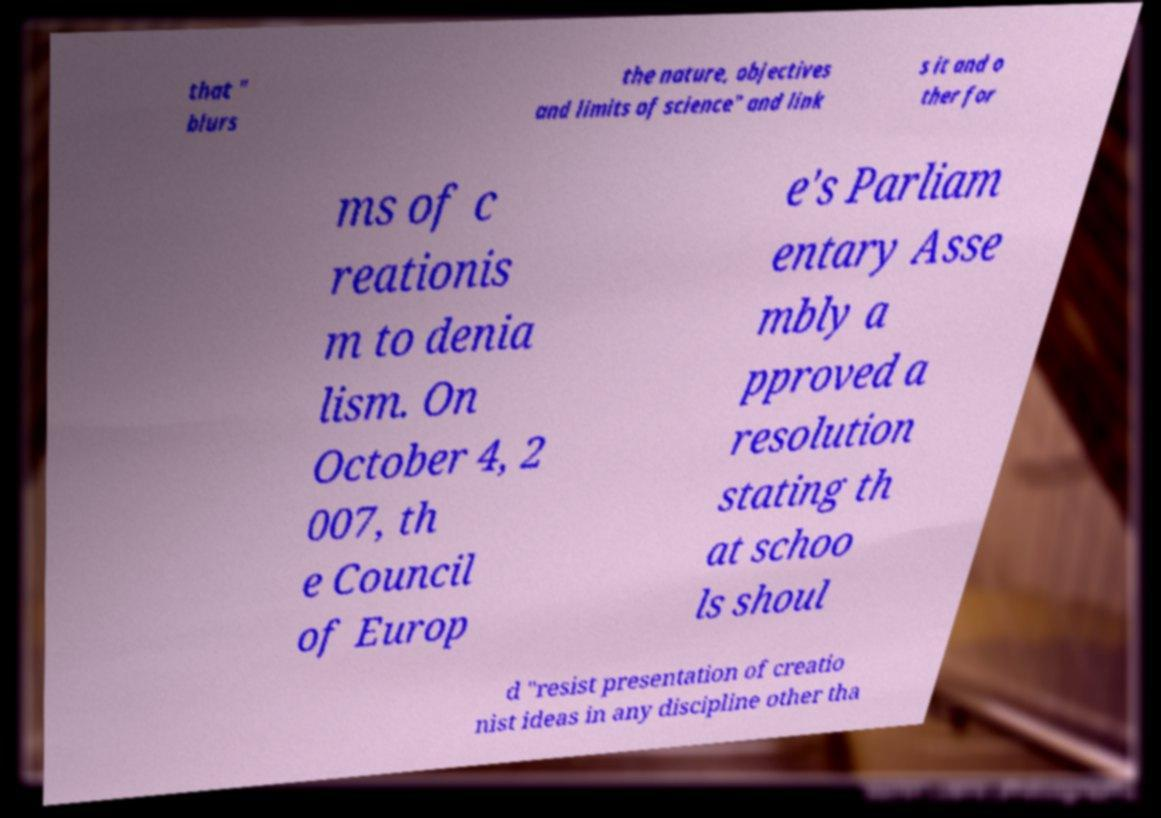Please read and relay the text visible in this image. What does it say? that " blurs the nature, objectives and limits of science" and link s it and o ther for ms of c reationis m to denia lism. On October 4, 2 007, th e Council of Europ e's Parliam entary Asse mbly a pproved a resolution stating th at schoo ls shoul d "resist presentation of creatio nist ideas in any discipline other tha 